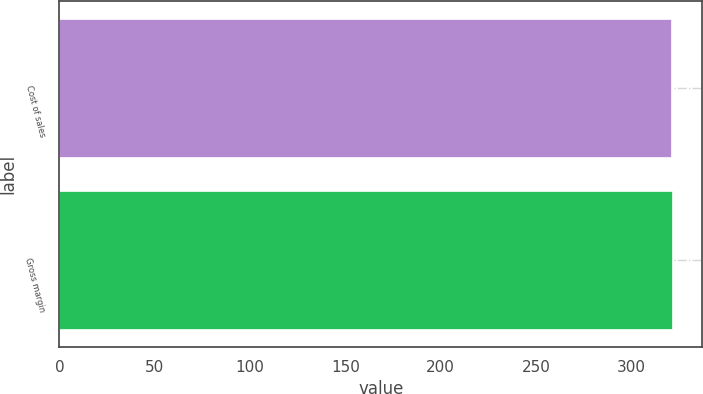Convert chart to OTSL. <chart><loc_0><loc_0><loc_500><loc_500><bar_chart><fcel>Cost of sales<fcel>Gross margin<nl><fcel>321<fcel>321.1<nl></chart> 